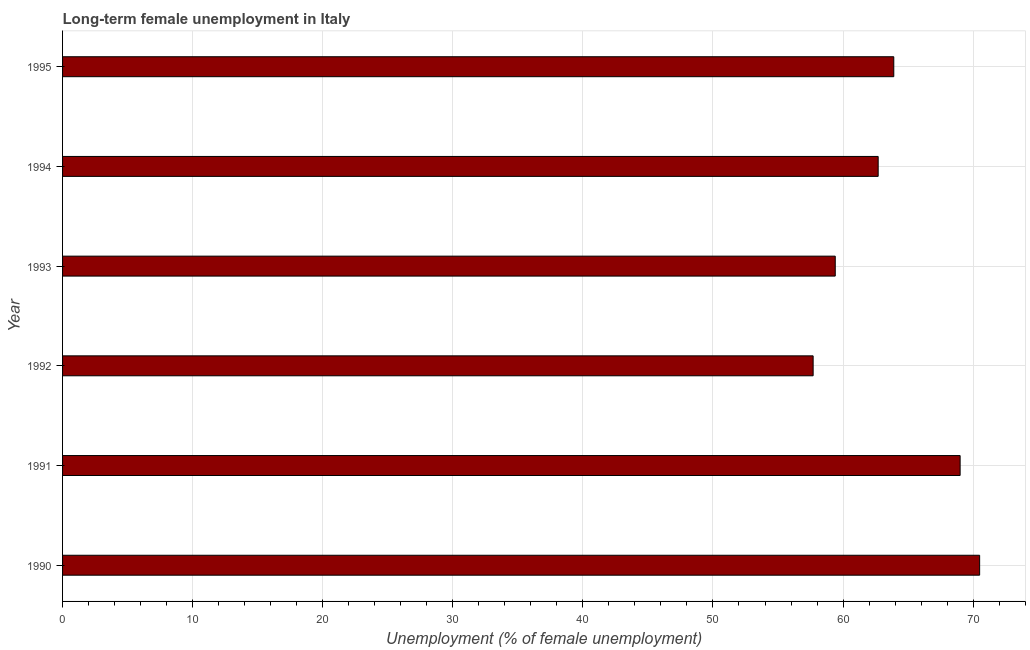Does the graph contain any zero values?
Your answer should be compact. No. What is the title of the graph?
Make the answer very short. Long-term female unemployment in Italy. What is the label or title of the X-axis?
Give a very brief answer. Unemployment (% of female unemployment). What is the label or title of the Y-axis?
Your answer should be very brief. Year. Across all years, what is the maximum long-term female unemployment?
Your answer should be compact. 70.5. Across all years, what is the minimum long-term female unemployment?
Your answer should be compact. 57.7. In which year was the long-term female unemployment maximum?
Keep it short and to the point. 1990. In which year was the long-term female unemployment minimum?
Keep it short and to the point. 1992. What is the sum of the long-term female unemployment?
Your answer should be very brief. 383.2. What is the difference between the long-term female unemployment in 1990 and 1993?
Your answer should be very brief. 11.1. What is the average long-term female unemployment per year?
Ensure brevity in your answer.  63.87. What is the median long-term female unemployment?
Ensure brevity in your answer.  63.3. What is the ratio of the long-term female unemployment in 1991 to that in 1993?
Give a very brief answer. 1.16. What is the difference between the highest and the second highest long-term female unemployment?
Keep it short and to the point. 1.5. In how many years, is the long-term female unemployment greater than the average long-term female unemployment taken over all years?
Your answer should be very brief. 3. How many bars are there?
Offer a very short reply. 6. Are all the bars in the graph horizontal?
Ensure brevity in your answer.  Yes. What is the difference between two consecutive major ticks on the X-axis?
Ensure brevity in your answer.  10. Are the values on the major ticks of X-axis written in scientific E-notation?
Make the answer very short. No. What is the Unemployment (% of female unemployment) in 1990?
Your response must be concise. 70.5. What is the Unemployment (% of female unemployment) of 1992?
Keep it short and to the point. 57.7. What is the Unemployment (% of female unemployment) of 1993?
Offer a very short reply. 59.4. What is the Unemployment (% of female unemployment) of 1994?
Provide a succinct answer. 62.7. What is the Unemployment (% of female unemployment) in 1995?
Your response must be concise. 63.9. What is the difference between the Unemployment (% of female unemployment) in 1990 and 1991?
Your answer should be compact. 1.5. What is the difference between the Unemployment (% of female unemployment) in 1990 and 1993?
Your response must be concise. 11.1. What is the difference between the Unemployment (% of female unemployment) in 1990 and 1994?
Offer a very short reply. 7.8. What is the difference between the Unemployment (% of female unemployment) in 1990 and 1995?
Your answer should be very brief. 6.6. What is the difference between the Unemployment (% of female unemployment) in 1991 and 1993?
Your answer should be compact. 9.6. What is the difference between the Unemployment (% of female unemployment) in 1991 and 1994?
Your response must be concise. 6.3. What is the difference between the Unemployment (% of female unemployment) in 1992 and 1993?
Provide a short and direct response. -1.7. What is the difference between the Unemployment (% of female unemployment) in 1993 and 1994?
Your response must be concise. -3.3. What is the ratio of the Unemployment (% of female unemployment) in 1990 to that in 1992?
Keep it short and to the point. 1.22. What is the ratio of the Unemployment (% of female unemployment) in 1990 to that in 1993?
Make the answer very short. 1.19. What is the ratio of the Unemployment (% of female unemployment) in 1990 to that in 1994?
Make the answer very short. 1.12. What is the ratio of the Unemployment (% of female unemployment) in 1990 to that in 1995?
Provide a short and direct response. 1.1. What is the ratio of the Unemployment (% of female unemployment) in 1991 to that in 1992?
Keep it short and to the point. 1.2. What is the ratio of the Unemployment (% of female unemployment) in 1991 to that in 1993?
Provide a short and direct response. 1.16. What is the ratio of the Unemployment (% of female unemployment) in 1991 to that in 1995?
Ensure brevity in your answer.  1.08. What is the ratio of the Unemployment (% of female unemployment) in 1992 to that in 1994?
Your answer should be compact. 0.92. What is the ratio of the Unemployment (% of female unemployment) in 1992 to that in 1995?
Ensure brevity in your answer.  0.9. What is the ratio of the Unemployment (% of female unemployment) in 1993 to that in 1994?
Make the answer very short. 0.95. What is the ratio of the Unemployment (% of female unemployment) in 1993 to that in 1995?
Give a very brief answer. 0.93. What is the ratio of the Unemployment (% of female unemployment) in 1994 to that in 1995?
Make the answer very short. 0.98. 